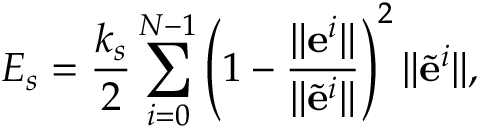<formula> <loc_0><loc_0><loc_500><loc_500>E _ { s } = \frac { k _ { s } } { 2 } \sum _ { i = 0 } ^ { N - 1 } \left ( 1 - \frac { \| e ^ { i } \| } { \| \tilde { e } ^ { i } \| } \right ) ^ { 2 } \| \tilde { e } ^ { i } \| ,</formula> 